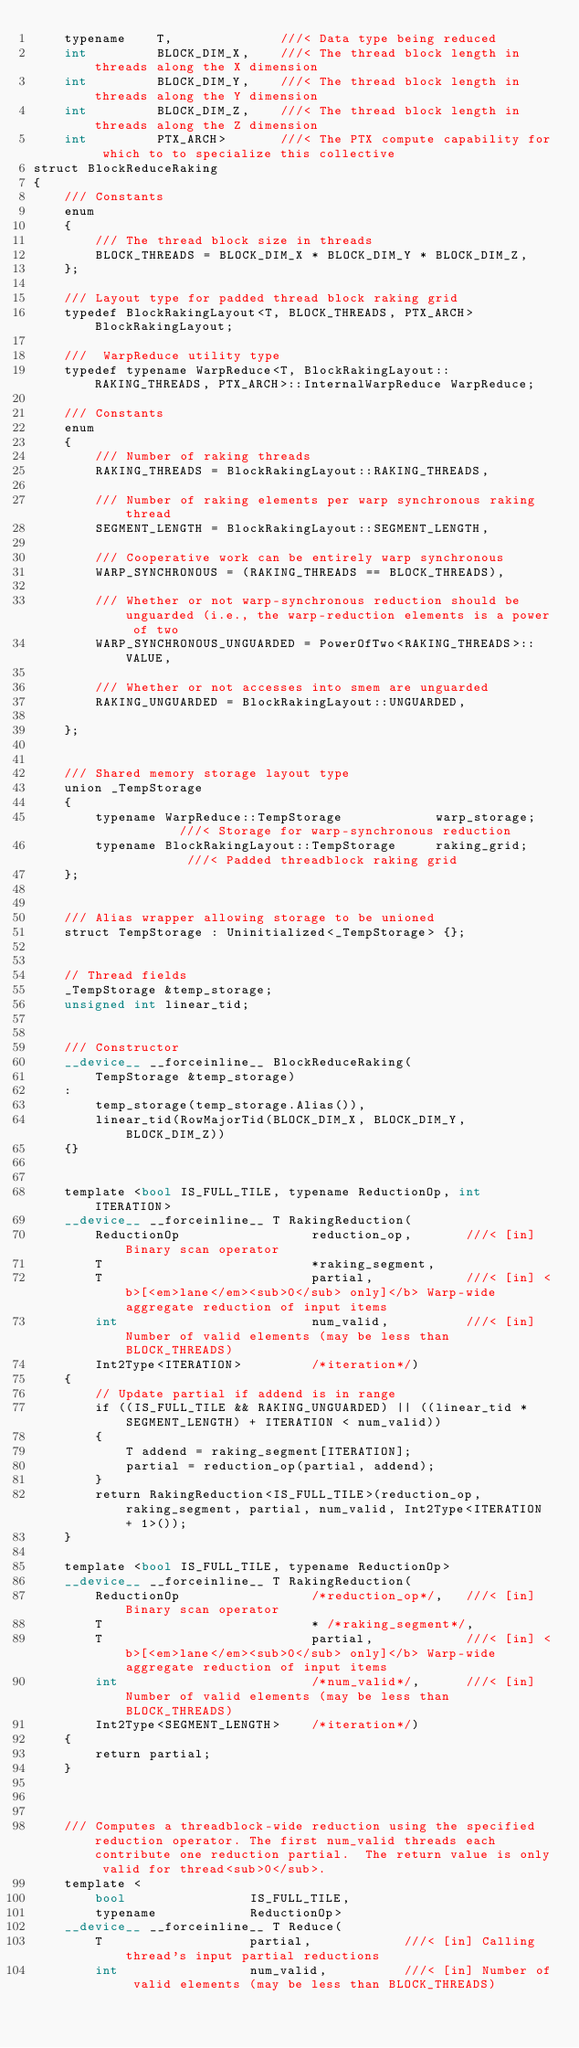<code> <loc_0><loc_0><loc_500><loc_500><_Cuda_>    typename    T,              ///< Data type being reduced
    int         BLOCK_DIM_X,    ///< The thread block length in threads along the X dimension
    int         BLOCK_DIM_Y,    ///< The thread block length in threads along the Y dimension
    int         BLOCK_DIM_Z,    ///< The thread block length in threads along the Z dimension
    int         PTX_ARCH>       ///< The PTX compute capability for which to to specialize this collective
struct BlockReduceRaking
{
    /// Constants
    enum
    {
        /// The thread block size in threads
        BLOCK_THREADS = BLOCK_DIM_X * BLOCK_DIM_Y * BLOCK_DIM_Z,
    };

    /// Layout type for padded thread block raking grid
    typedef BlockRakingLayout<T, BLOCK_THREADS, PTX_ARCH> BlockRakingLayout;

    ///  WarpReduce utility type
    typedef typename WarpReduce<T, BlockRakingLayout::RAKING_THREADS, PTX_ARCH>::InternalWarpReduce WarpReduce;

    /// Constants
    enum
    {
        /// Number of raking threads
        RAKING_THREADS = BlockRakingLayout::RAKING_THREADS,

        /// Number of raking elements per warp synchronous raking thread
        SEGMENT_LENGTH = BlockRakingLayout::SEGMENT_LENGTH,

        /// Cooperative work can be entirely warp synchronous
        WARP_SYNCHRONOUS = (RAKING_THREADS == BLOCK_THREADS),

        /// Whether or not warp-synchronous reduction should be unguarded (i.e., the warp-reduction elements is a power of two
        WARP_SYNCHRONOUS_UNGUARDED = PowerOfTwo<RAKING_THREADS>::VALUE,

        /// Whether or not accesses into smem are unguarded
        RAKING_UNGUARDED = BlockRakingLayout::UNGUARDED,

    };


    /// Shared memory storage layout type
    union _TempStorage
    {
        typename WarpReduce::TempStorage            warp_storage;        ///< Storage for warp-synchronous reduction
        typename BlockRakingLayout::TempStorage     raking_grid;         ///< Padded threadblock raking grid
    };


    /// Alias wrapper allowing storage to be unioned
    struct TempStorage : Uninitialized<_TempStorage> {};


    // Thread fields
    _TempStorage &temp_storage;
    unsigned int linear_tid;


    /// Constructor
    __device__ __forceinline__ BlockReduceRaking(
        TempStorage &temp_storage)
    :
        temp_storage(temp_storage.Alias()),
        linear_tid(RowMajorTid(BLOCK_DIM_X, BLOCK_DIM_Y, BLOCK_DIM_Z))
    {}


    template <bool IS_FULL_TILE, typename ReductionOp, int ITERATION>
    __device__ __forceinline__ T RakingReduction(
        ReductionOp                 reduction_op,       ///< [in] Binary scan operator
        T                           *raking_segment,
        T                           partial,            ///< [in] <b>[<em>lane</em><sub>0</sub> only]</b> Warp-wide aggregate reduction of input items
        int                         num_valid,          ///< [in] Number of valid elements (may be less than BLOCK_THREADS)
        Int2Type<ITERATION>         /*iteration*/)
    {
        // Update partial if addend is in range
        if ((IS_FULL_TILE && RAKING_UNGUARDED) || ((linear_tid * SEGMENT_LENGTH) + ITERATION < num_valid))
        {
            T addend = raking_segment[ITERATION];
            partial = reduction_op(partial, addend);
        }
        return RakingReduction<IS_FULL_TILE>(reduction_op, raking_segment, partial, num_valid, Int2Type<ITERATION + 1>());
    }

    template <bool IS_FULL_TILE, typename ReductionOp>
    __device__ __forceinline__ T RakingReduction(
        ReductionOp                 /*reduction_op*/,   ///< [in] Binary scan operator
        T                           * /*raking_segment*/,
        T                           partial,            ///< [in] <b>[<em>lane</em><sub>0</sub> only]</b> Warp-wide aggregate reduction of input items
        int                         /*num_valid*/,      ///< [in] Number of valid elements (may be less than BLOCK_THREADS)
        Int2Type<SEGMENT_LENGTH>    /*iteration*/)
    {
        return partial;
    }



    /// Computes a threadblock-wide reduction using the specified reduction operator. The first num_valid threads each contribute one reduction partial.  The return value is only valid for thread<sub>0</sub>.
    template <
        bool                IS_FULL_TILE,
        typename            ReductionOp>
    __device__ __forceinline__ T Reduce(
        T                   partial,            ///< [in] Calling thread's input partial reductions
        int                 num_valid,          ///< [in] Number of valid elements (may be less than BLOCK_THREADS)</code> 